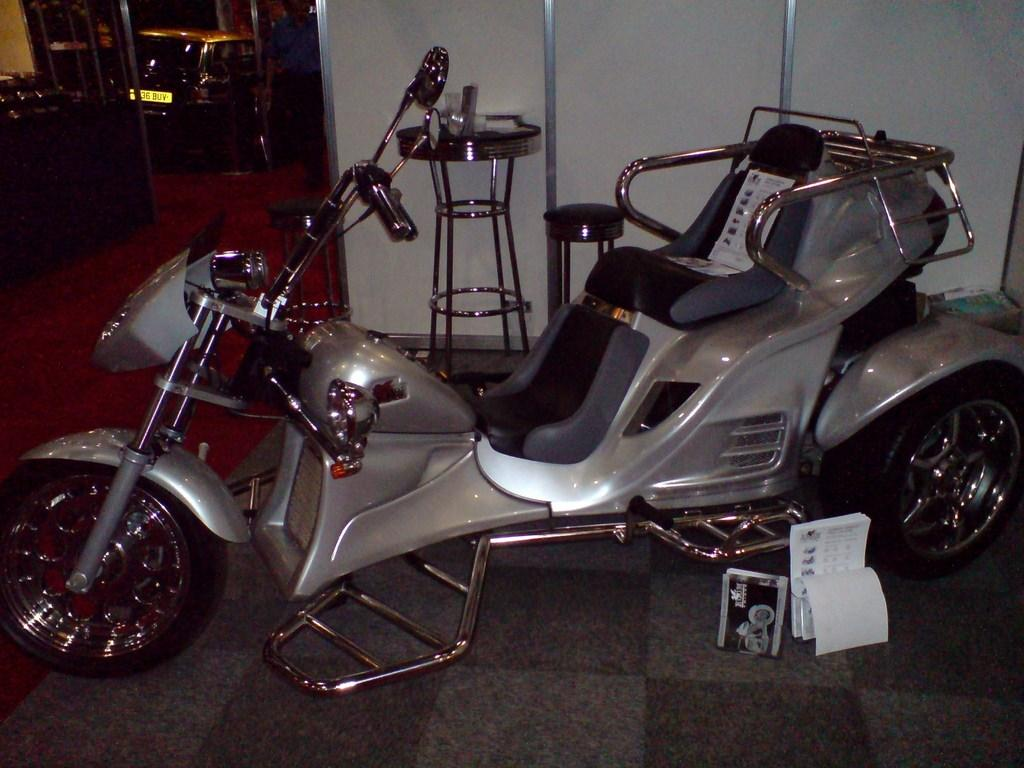What is the main subject in the center of the image? There is a vehicle in the center of the image. What can be seen in the background of the image? There are stools, a board, vehicles, and other objects in the background of the image. What is at the bottom of the image? There is a carpet and a floor visible at the bottom of the image. Where is the coal stored in the image? There is no coal present in the image. What type of table is visible in the image? There is no table present in the image. 